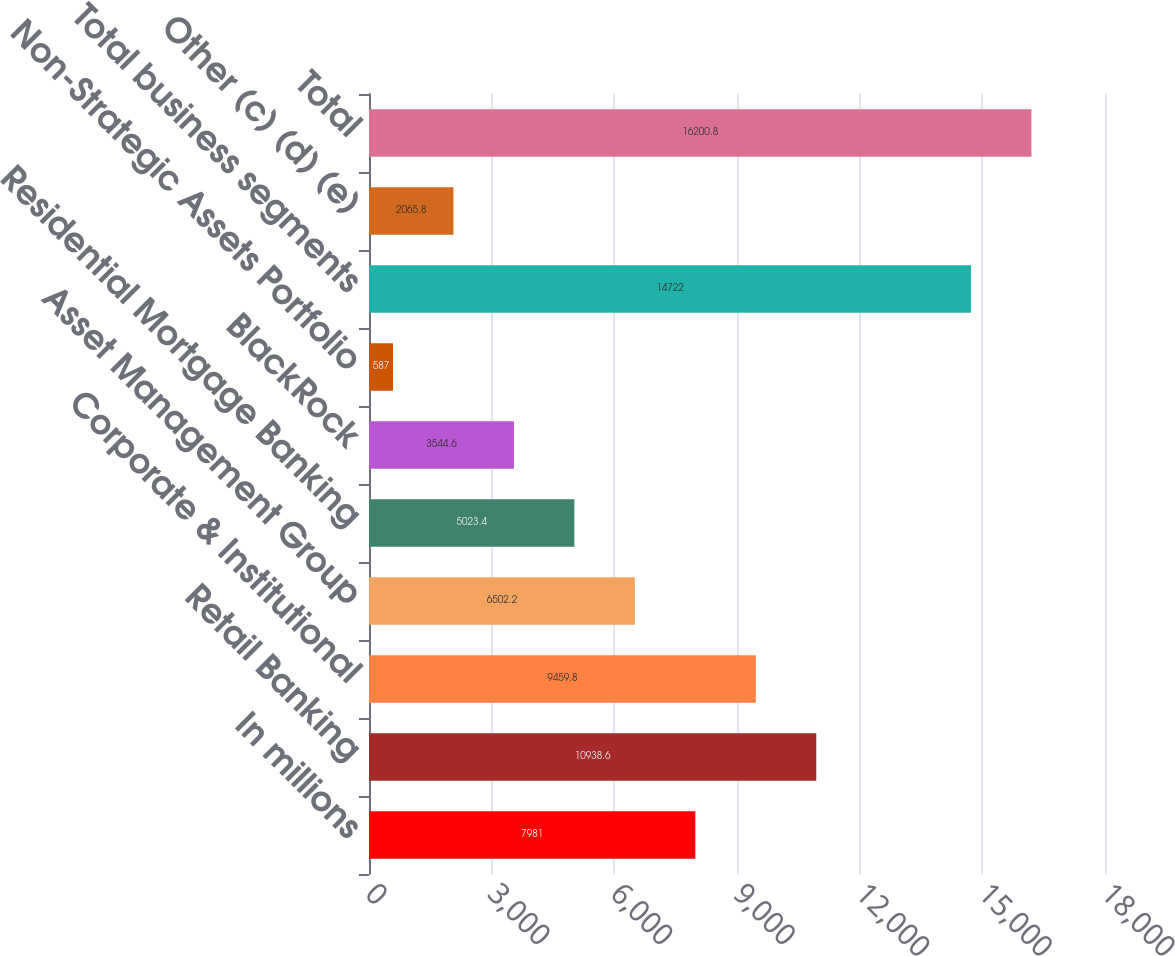Convert chart. <chart><loc_0><loc_0><loc_500><loc_500><bar_chart><fcel>In millions<fcel>Retail Banking<fcel>Corporate & Institutional<fcel>Asset Management Group<fcel>Residential Mortgage Banking<fcel>BlackRock<fcel>Non-Strategic Assets Portfolio<fcel>Total business segments<fcel>Other (c) (d) (e)<fcel>Total<nl><fcel>7981<fcel>10938.6<fcel>9459.8<fcel>6502.2<fcel>5023.4<fcel>3544.6<fcel>587<fcel>14722<fcel>2065.8<fcel>16200.8<nl></chart> 